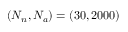<formula> <loc_0><loc_0><loc_500><loc_500>( N _ { n } , N _ { a } ) = ( 3 0 , 2 0 0 0 )</formula> 